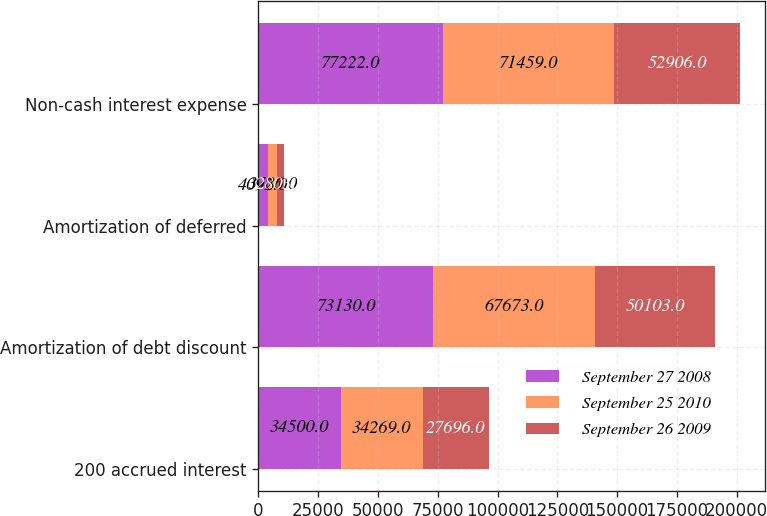Convert chart to OTSL. <chart><loc_0><loc_0><loc_500><loc_500><stacked_bar_chart><ecel><fcel>200 accrued interest<fcel>Amortization of debt discount<fcel>Amortization of deferred<fcel>Non-cash interest expense<nl><fcel>September 27 2008<fcel>34500<fcel>73130<fcel>4092<fcel>77222<nl><fcel>September 25 2010<fcel>34269<fcel>67673<fcel>3786<fcel>71459<nl><fcel>September 26 2009<fcel>27696<fcel>50103<fcel>2803<fcel>52906<nl></chart> 